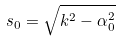<formula> <loc_0><loc_0><loc_500><loc_500>s _ { 0 } = \sqrt { k ^ { 2 } - \alpha _ { 0 } ^ { 2 } }</formula> 